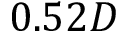<formula> <loc_0><loc_0><loc_500><loc_500>0 . 5 2 D</formula> 